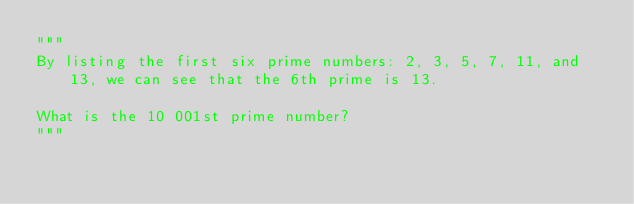<code> <loc_0><loc_0><loc_500><loc_500><_Python_>"""
By listing the first six prime numbers: 2, 3, 5, 7, 11, and 13, we can see that the 6th prime is 13.

What is the 10 001st prime number?
"""</code> 